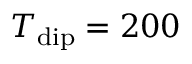Convert formula to latex. <formula><loc_0><loc_0><loc_500><loc_500>T _ { d i p } = 2 0 0</formula> 